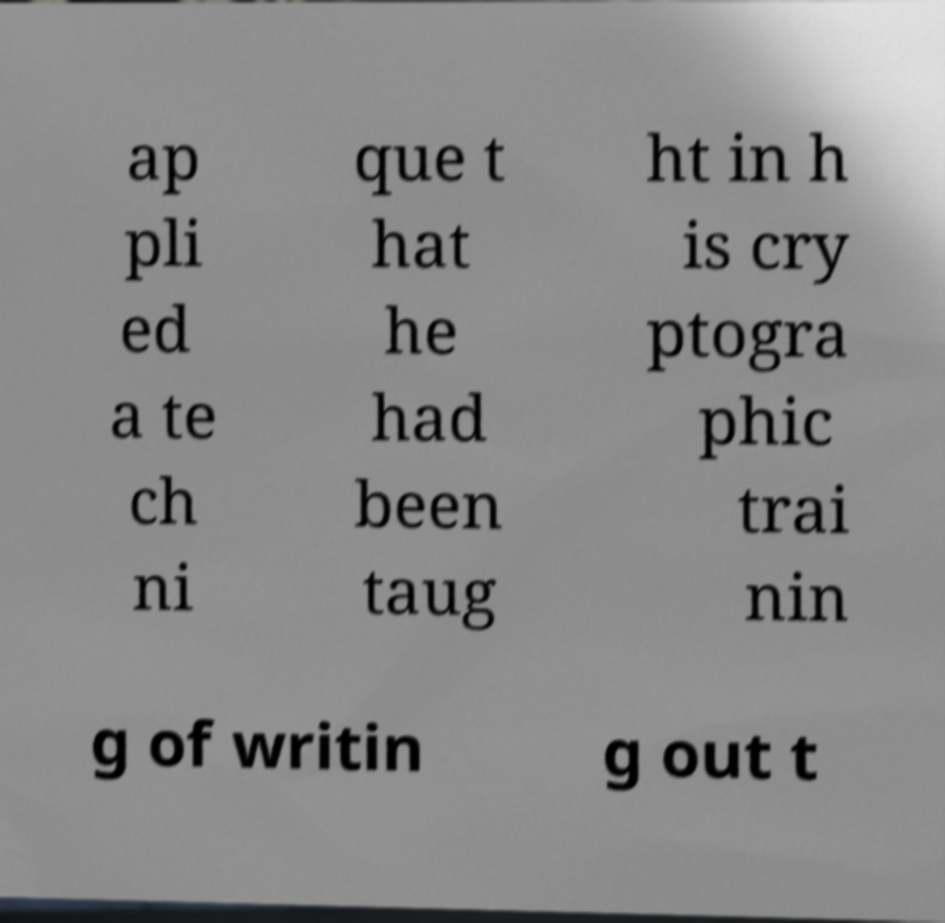Please read and relay the text visible in this image. What does it say? ap pli ed a te ch ni que t hat he had been taug ht in h is cry ptogra phic trai nin g of writin g out t 